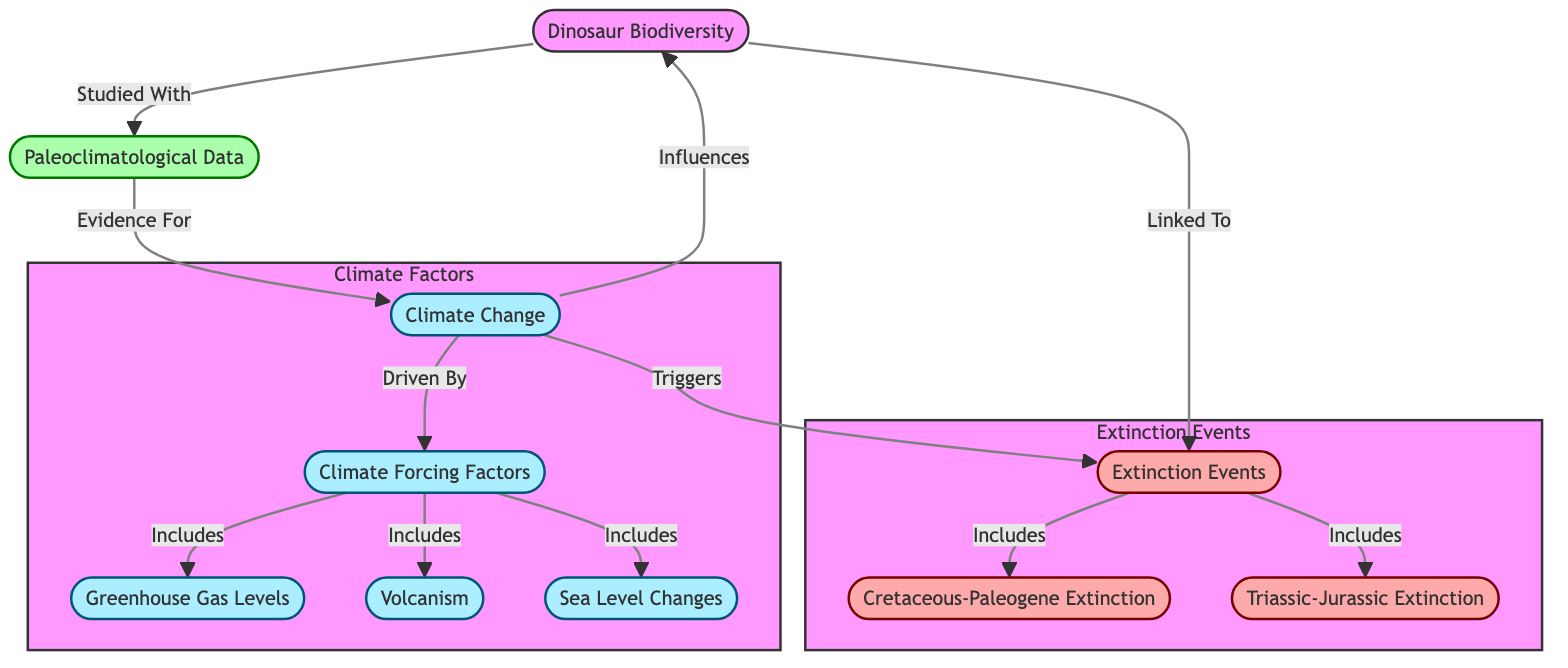What is the main focus of the diagram? The diagram primarily illustrates the impact of Climate Change on Dinosaur Biodiversity, linking various extinction events and paleoclimatological data together.
Answer: Climate Change on Dinosaur Biodiversity How many extinction events are included in the diagram? There are two extinction events explicitly included in the diagram: the Cretaceous-Paleogene Extinction and the Triassic-Jurassic Extinction.
Answer: 2 What are the climate forcing factors listed in the diagram? The diagram lists three climate forcing factors: Greenhouse Gas Levels, Volcanism, and Sea Level Changes.
Answer: Greenhouse Gas Levels, Volcanism, Sea Level Changes Which node is directly influenced by climate change? Dinosaur Biodiversity is directly influenced by Climate Change in the diagram.
Answer: Dinosaur Biodiversity What type of relationship exists between Paleoclimatological Data and Climate Change? Paleoclimatological Data provides evidence for Climate Change, indicating that they have a supportive relationship.
Answer: Evidence For How many nodes represent extinction events, and what are they? There are two nodes representing extinction events: Cretaceous-Paleogene Extinction and Triassic-Jurassic Extinction.
Answer: 2: Cretaceous-Paleogene Extinction, Triassic-Jurassic Extinction What drives climate change, according to the diagram? According to the diagram, climate change is driven by climate forcing factors, which include greenhouse gas levels, volcanism, and sea level changes.
Answer: Climate Forcing Factors Which climate forcing factor is associated with volcanic activity? Volcanism is the climate forcing factor associated with volcanic activity as indicated in the diagram.
Answer: Volcanism How does climate change relate to extinction events? The diagram indicates that climate change triggers extinction events, showing a direct causal relationship between them.
Answer: Triggers 